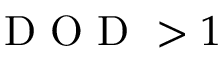Convert formula to latex. <formula><loc_0><loc_0><loc_500><loc_500>D O D > 1</formula> 